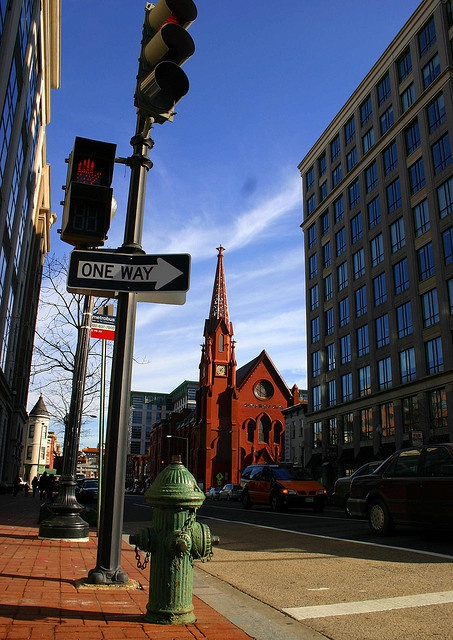Describe the objects in this image and their specific colors. I can see fire hydrant in navy, black, olive, and darkgreen tones, car in navy, black, gray, and darkgreen tones, traffic light in navy, black, blue, olive, and maroon tones, traffic light in navy, black, maroon, olive, and lightblue tones, and car in navy, black, maroon, and gray tones in this image. 